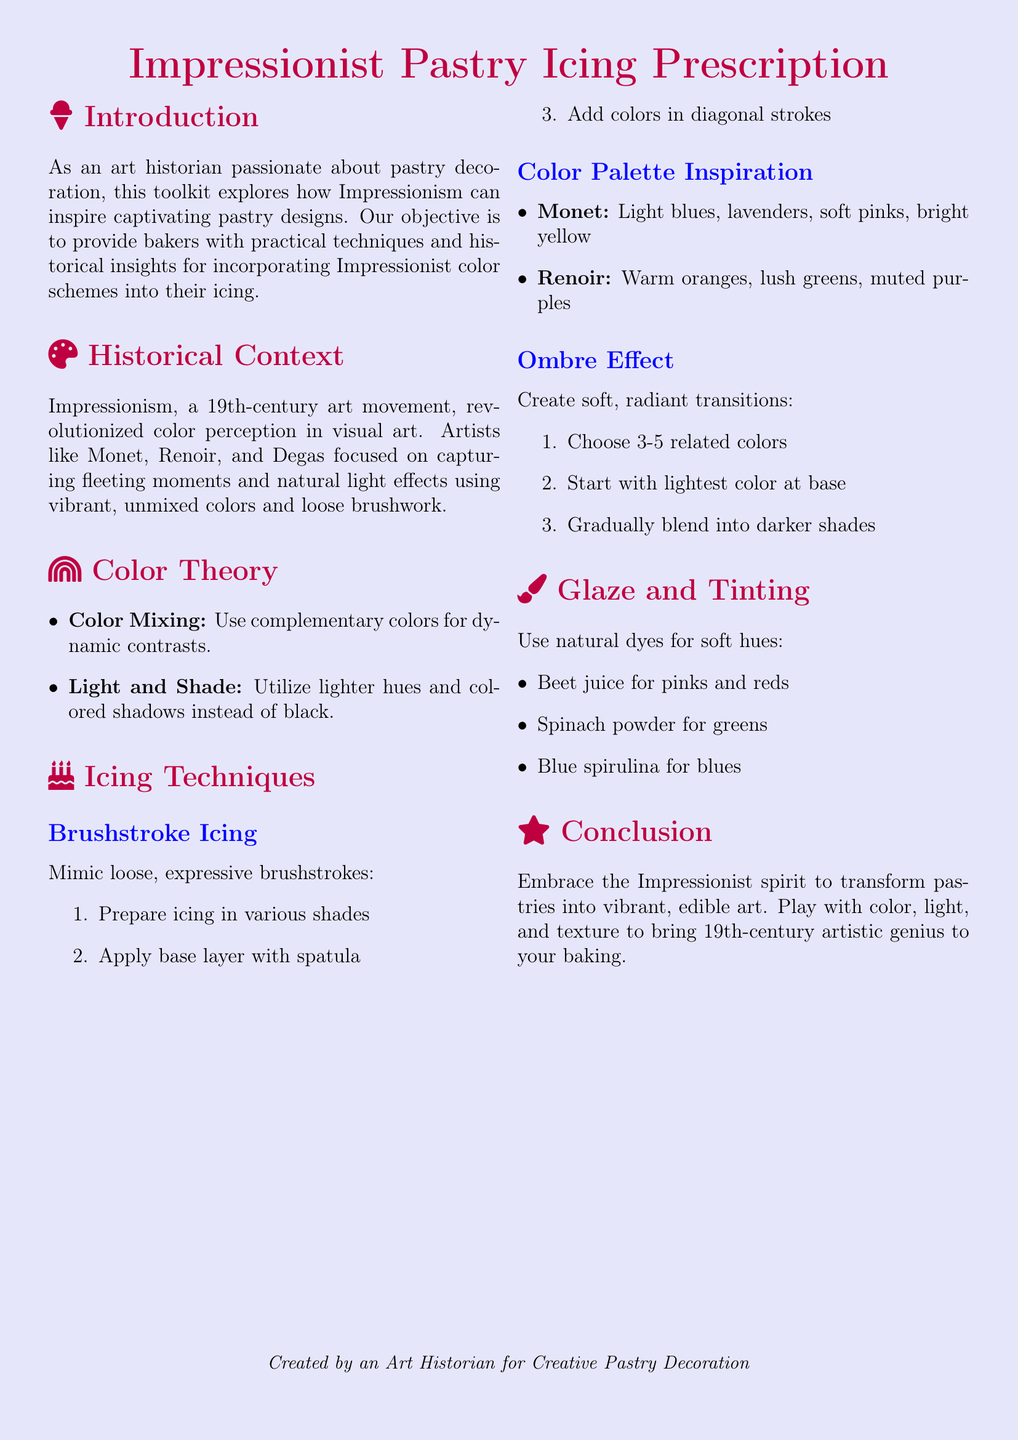What is the title of the document? The title is prominently displayed at the top of the document, highlighting the main theme.
Answer: Impressionist Pastry Icing Prescription Who are some of the Impressionist artists mentioned? The document references key artists associated with the Impressionist movement, which are significant for understanding the color schemes.
Answer: Monet, Renoir, Degas What colors are inspired by Monet? The document lists specific colors that can be used based on Monet's palette, essential for the proposed icing techniques.
Answer: Light blues, lavenders, soft pinks, bright yellow What is the first step in creating Brushstroke Icing? The document details the techniques suggested for creating a specific type of icing, starting with initial preparation.
Answer: Prepare icing in various shades How many related colors are suggested for creating an Ombre Effect? The document specifies a range of colors to ensure a smooth transition in this icing technique.
Answer: 3-5 Which natural dye can be used for pinks and reds? The document provides options for coloring icing naturally, relevant for achieving desired hues.
Answer: Beet juice What is the main goal of embracing Impressionist techniques in pastries? The document concludes with the intended outcome of applying Impressionist color schemes to baking, encapsulating the essence of the toolkit.
Answer: Transform pastries into vibrant, edible art What does the Introduction section focus on? The document outlines the primary focus of the introduction, which sets the stage for the creative toolkit approach.
Answer: Exploring how Impressionism can inspire captivating pastry designs 